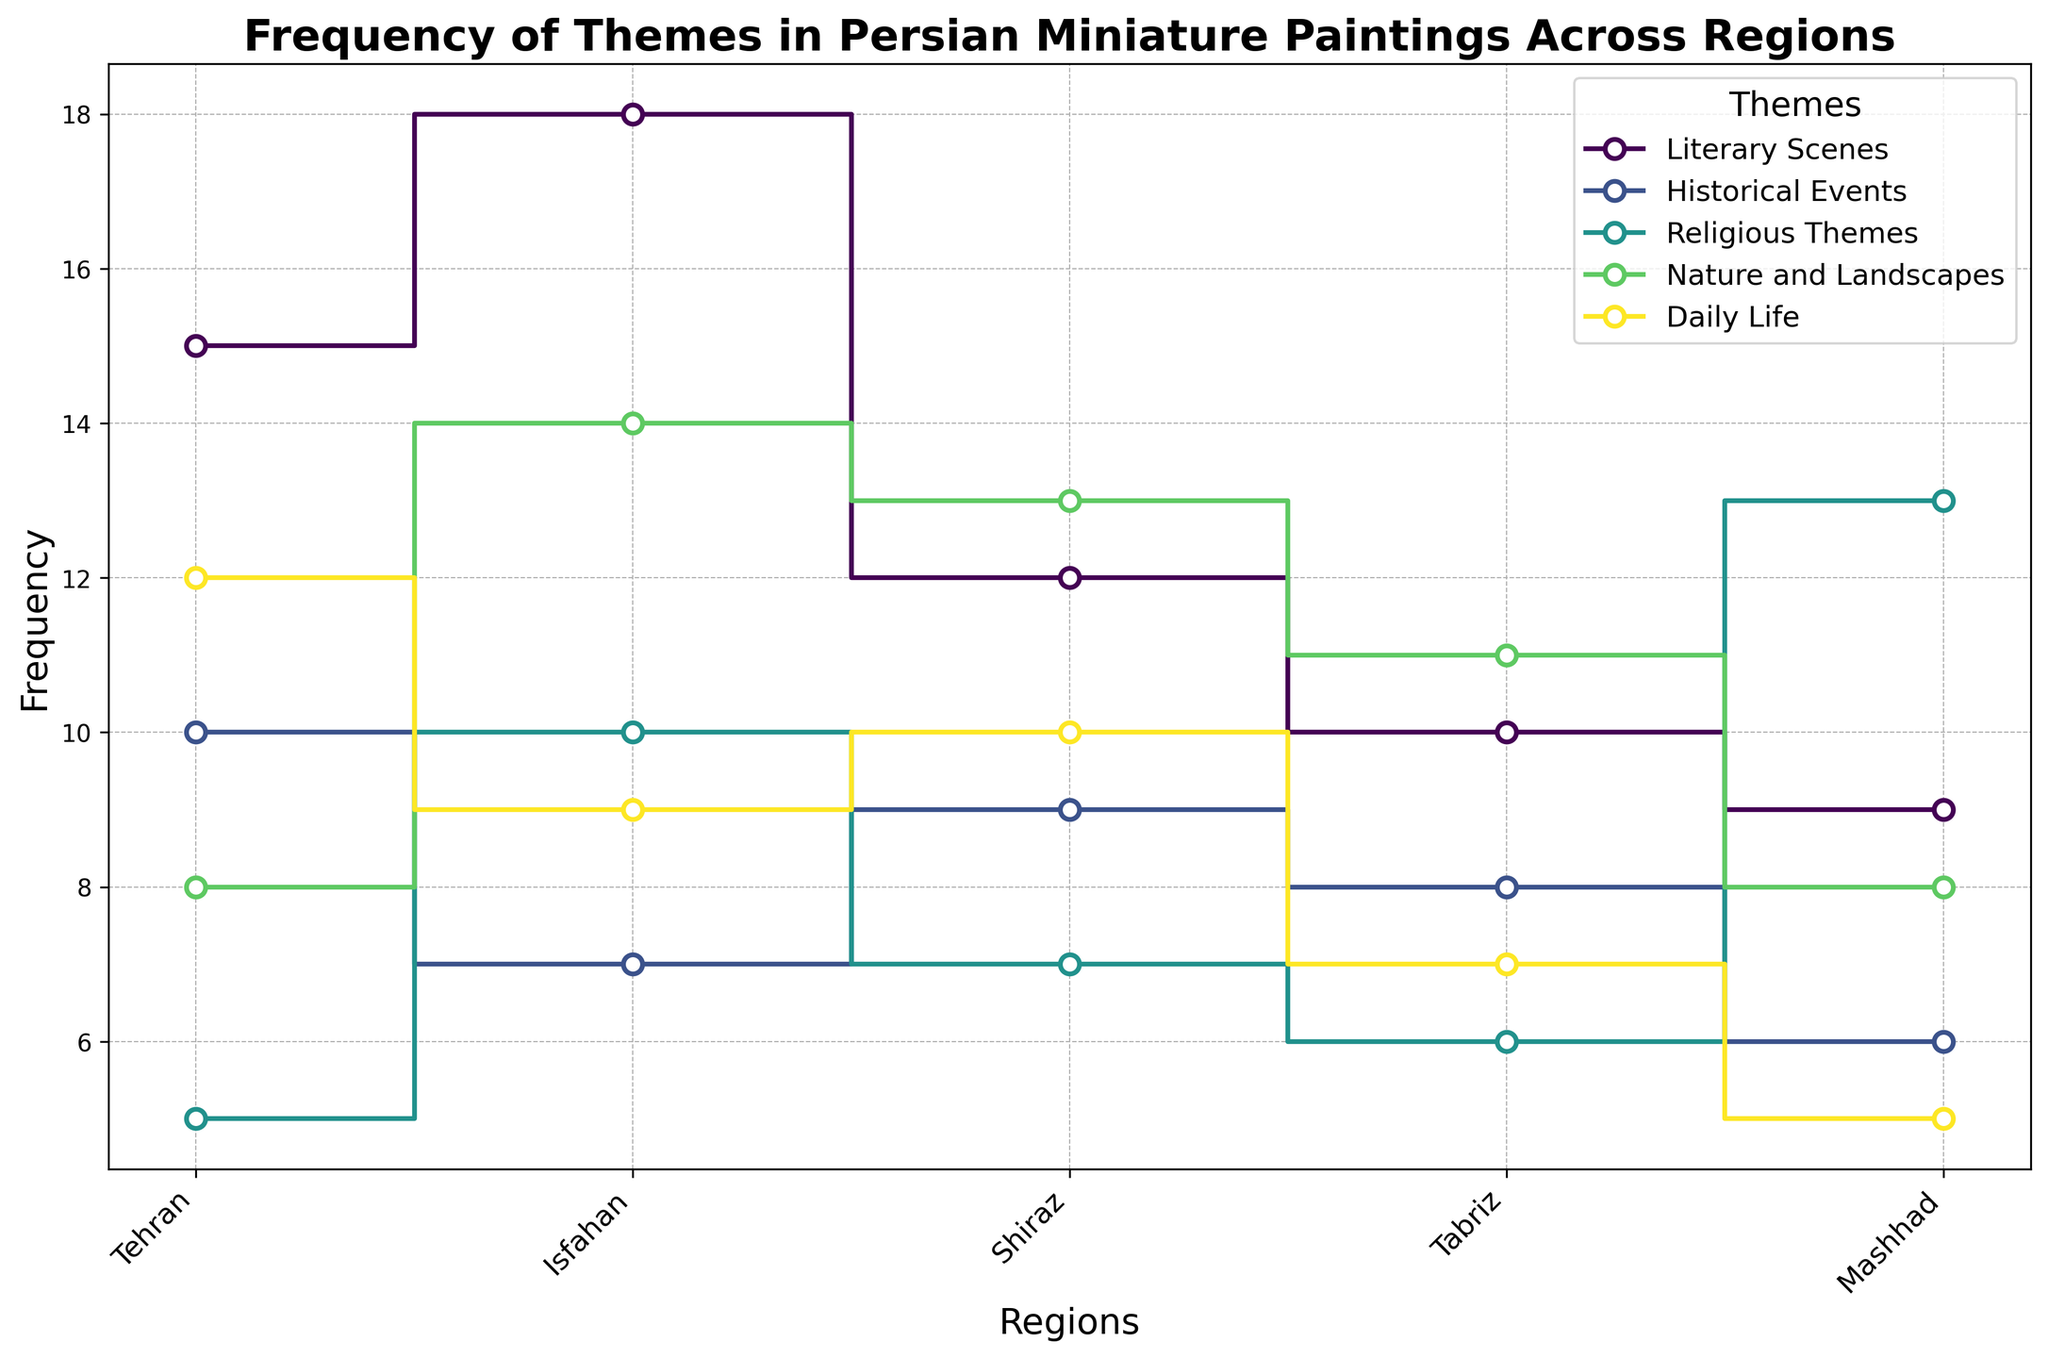Which region depicts the highest frequency of Literary Scenes? The step plot shows that the theme "Literary Scenes" has the highest point in Isfahan compared to other regions.
Answer: Isfahan Among Tehran, Isfahan, and Shiraz, which region has the least frequency of Historical Events? By comparing the heights of the step lines for "Historical Events" in these regions, the lowest value is seen in Isfahan.
Answer: Isfahan What is the total frequency of Religious Themes across all regions? Summing up all counts for "Religious Themes": 5 (Tehran) + 10 (Isfahan) + 7 (Shiraz) + 6 (Tabriz) + 13 (Mashhad) = 41.
Answer: 41 Which theme has the most varied frequency across the regions? Observing the range of the step lines for each theme reveals that the "Religious Themes" have the widest range between their highest (13 in Mashhad) and lowest (5 in Tehran) points.
Answer: Religious Themes How does the frequency of Daily Life in Shiraz compare to that in Tabriz? The step plot shows that the frequency of "Daily Life" in Shiraz is higher than in Tabriz. Shiraz has 10, while Tabriz has 7.
Answer: Shiraz is higher What is the average count of Nature and Landscapes across all regions? Summing the counts for "Nature and Landscapes" and dividing by the number of regions: (8 + 14 + 13 + 11 + 8) / 5 = 54 / 5 = 10.8.
Answer: 10.8 Which region has the most balanced frequency distribution across all themes? By visually inspecting the step lines, Tabriz seems to have relatively uniform step heights across all themes compared to other regions.
Answer: Tabriz What can be said about the trend of Historical Events from Tehran to Mashhad? The step line for "Historical Events" shows a downward trend moving from Tehran (10) to Mashhad (6).
Answer: Downward trend Are Nature and Landscapes more frequently depicted in Isfahan or Tehran? Comparing the step heights of "Nature and Landscapes," Isfahan (14) is higher than Tehran (8).
Answer: Isfahan What is the difference in frequency of Daily Life between Mashhad and Isfahan? Subtracting the two values: 9 (Isfahan) - 5 (Mashhad) = 4.
Answer: 4 